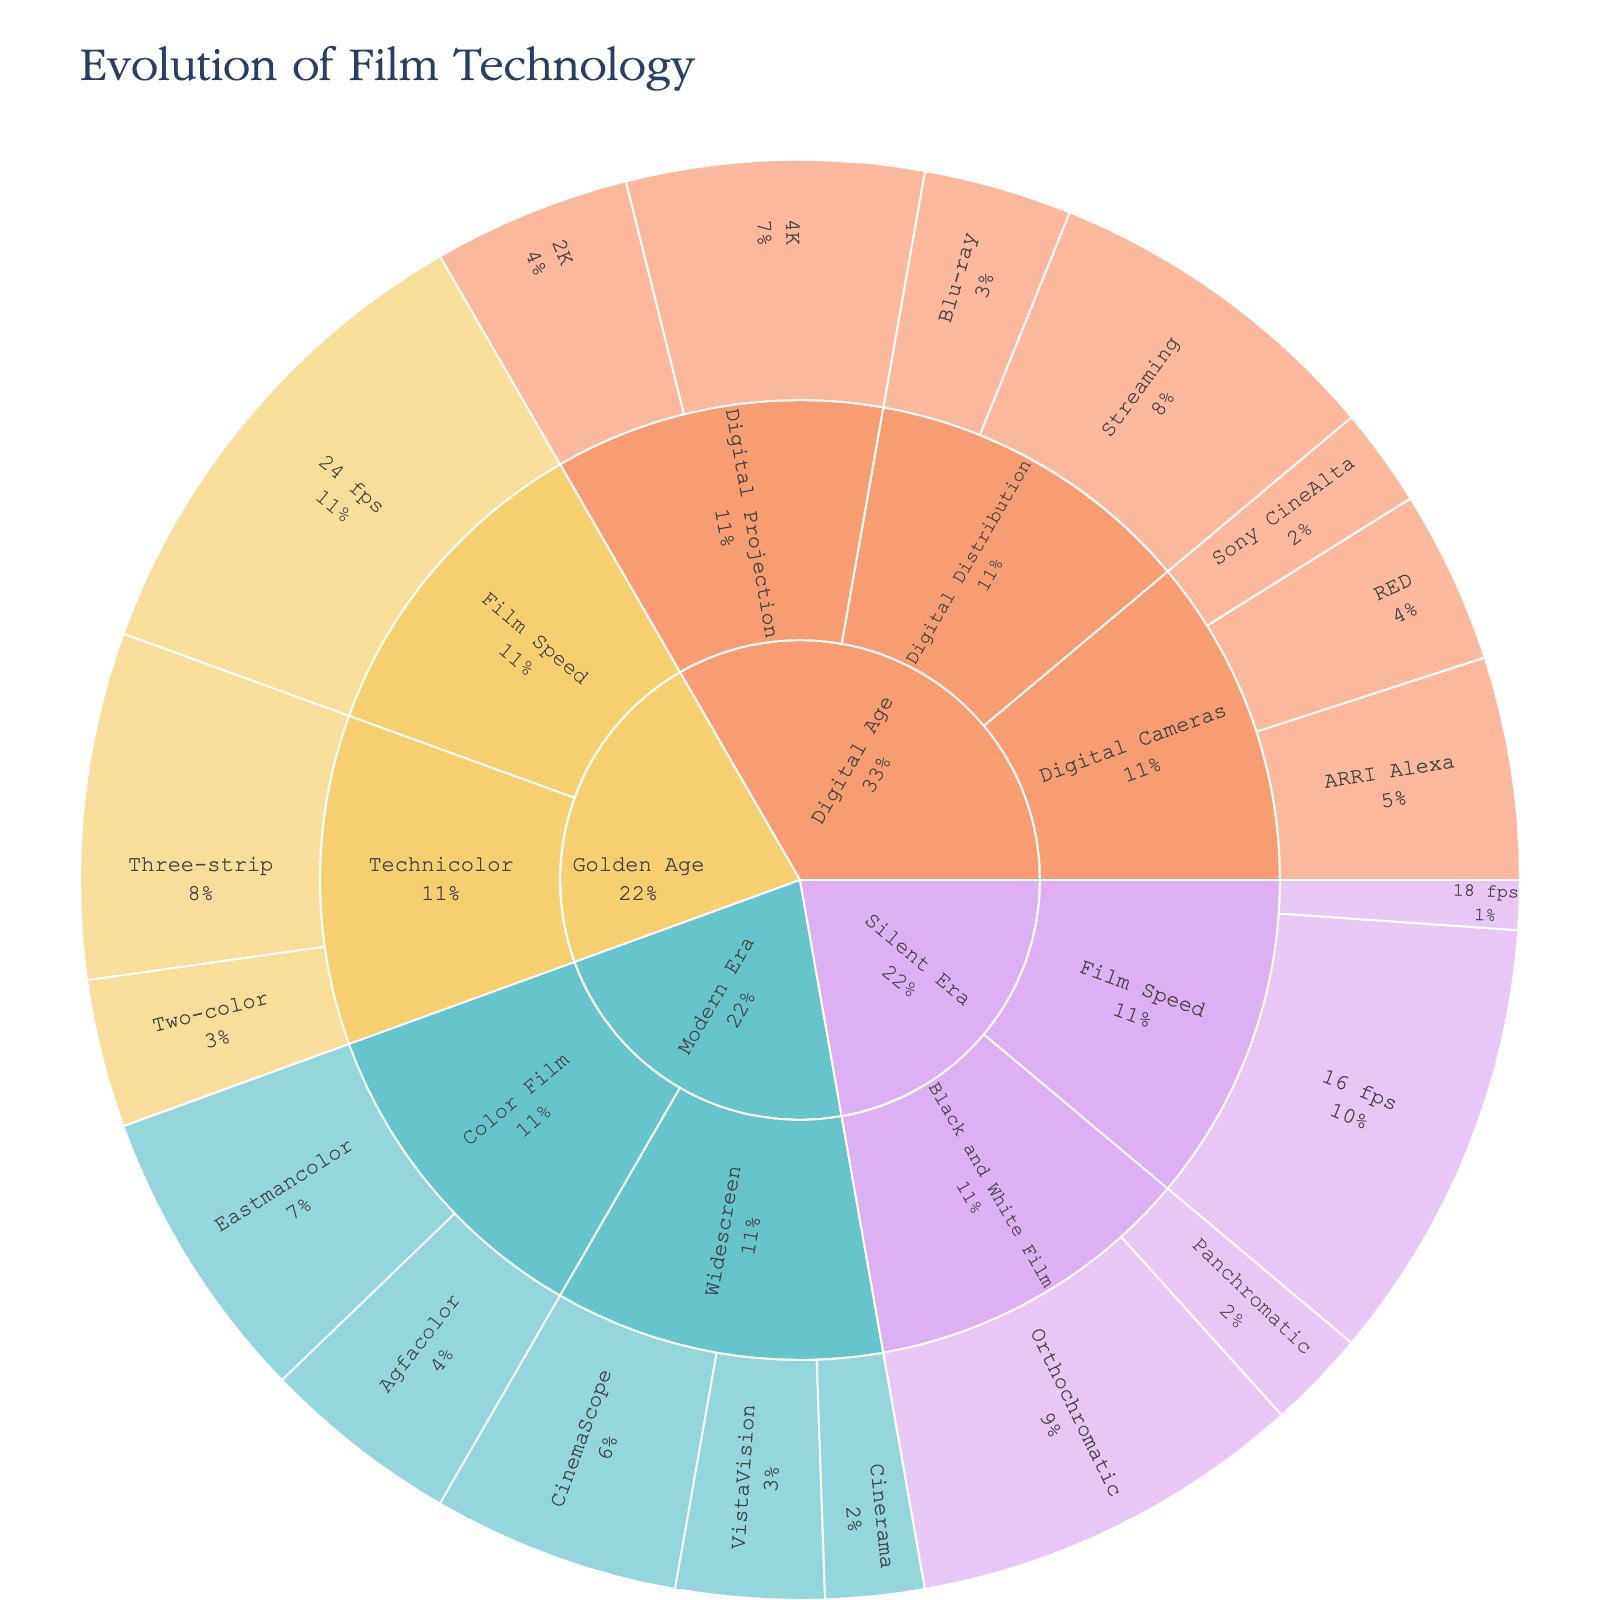What is the title of the Sunburst Plot? The title is generally located at the top of the figure and provides an overview of what the plot is about.
Answer: Evolution of Film Technology How many main categories does the plot have? The main categories are the first level of division in the Sunburst Plot, which are usually clearly segmented with distinct colors.
Answer: 4 Which era had the highest adoption rate for Technicolor Three-strip film? Locate the 'Technicolor' category under each era and compare the adoption rates of 'Three-strip' subcategory.
Answer: Golden Age What is the total adoption rate for all subcategories in the Silent Era? Sum the adoption rates of all subcategories under the 'Silent Era': Orthochromatic (80) + Panchromatic (20) + 16 fps (90) + 18 fps (10).
Answer: 200 Compare the adoption rates of 4K and 2K digital projection technologies. Which one is higher and by how much? Check the adoption rates under 'Digital Projection' subcategory in 'Digital Age': 4K (60) and 2K (40). Subtract the smaller from the larger.
Answer: 4K, higher by 20 Which category in the Digital Age has the highest individual adoption rate subcategory? Find the subcategories under 'Digital Age' and compare their rates: 4K (60), Streaming (70), etc. The one with the highest rate will be the answer.
Answer: Digital Distribution, Streaming What is the average adoption rate for the 'Film Speed' subcategory across all eras? Sum the adoption rates of 'Film Speed' across 'Silent Era' and 'Golden Age': (16 fps (90) + 18 fps (10) + 24 fps (100)) / 3 → Compute the average.
Answer: 67 Between 'Eastmancolor' and 'Agfacolor' in the Modern Era, which has a higher adoption rate? Compare the adoption rates under 'Color Film' subcategory in 'Modern Era'.
Answer: Eastmancolor How does the adoption rate for 'CinemaScope' compare to that of 'VistaVision'? Look at the 'Widescreen' subcategories under 'Modern Era' and compare their respective adoption rates: 'CinemaScope' (50) vs. 'VistaVision' (30).
Answer: CinemaScope is higher What percentage of the total adoption rate did the Digital Distribution category contribute in the Digital Age? Sum the adoption rates of all subcategories in the Digital Age. Then, divide the sum of 'Streaming' and 'Blu-ray' by the total and multiply by 100 to get the percentage.
Answer: 50% 